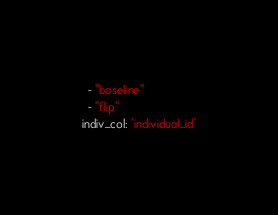Convert code to text. <code><loc_0><loc_0><loc_500><loc_500><_YAML_>  - "baseline"
  - "flip"
indiv_col: 'individual_id'
</code> 